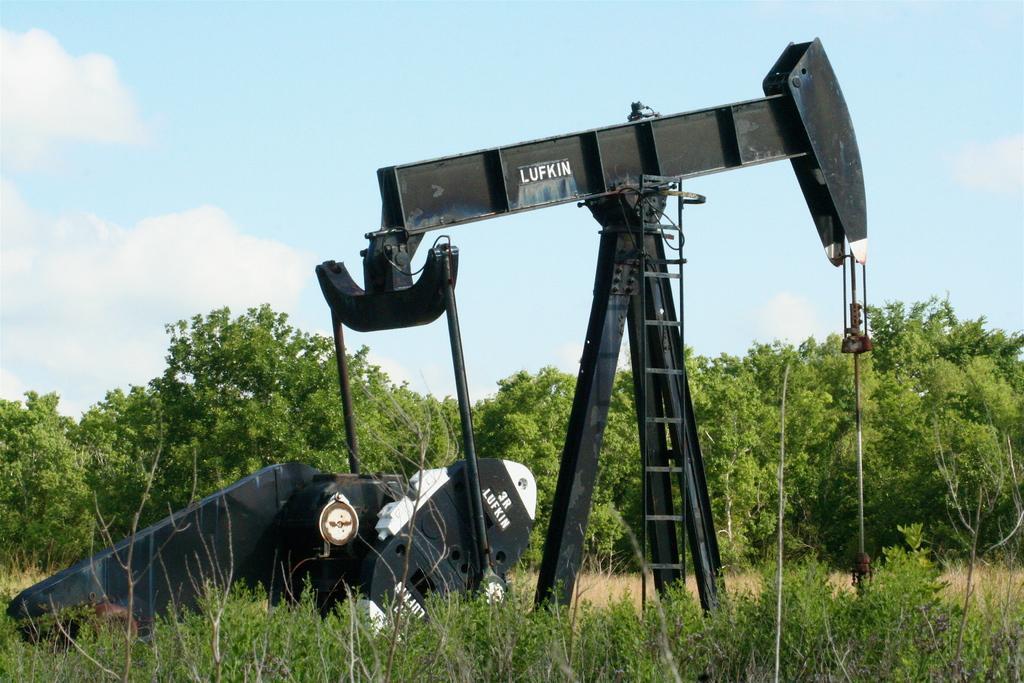Describe this image in one or two sentences. In this image I can see some object on the grass ground at the back there are so many trees. 